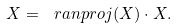Convert formula to latex. <formula><loc_0><loc_0><loc_500><loc_500>X = \ r a n p r o j ( X ) \cdot X .</formula> 